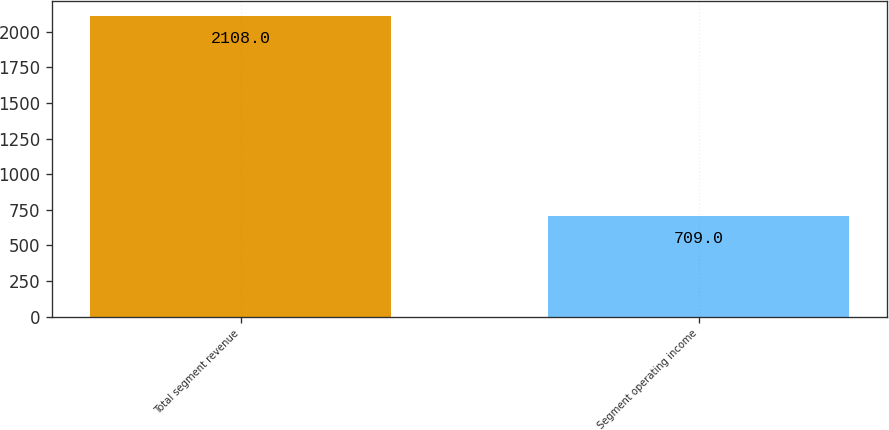Convert chart to OTSL. <chart><loc_0><loc_0><loc_500><loc_500><bar_chart><fcel>Total segment revenue<fcel>Segment operating income<nl><fcel>2108<fcel>709<nl></chart> 